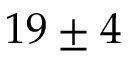Convert formula to latex. <formula><loc_0><loc_0><loc_500><loc_500>1 9 \pm 4</formula> 